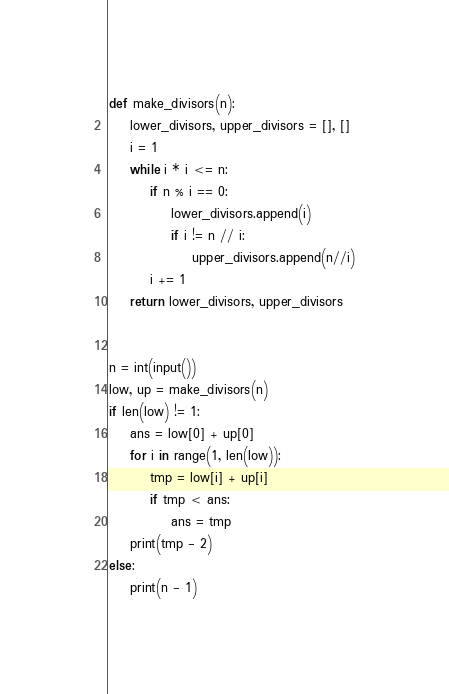<code> <loc_0><loc_0><loc_500><loc_500><_Python_>def make_divisors(n):
    lower_divisors, upper_divisors = [], []
    i = 1
    while i * i <= n:
        if n % i == 0:
            lower_divisors.append(i)
            if i != n // i:
                upper_divisors.append(n//i)
        i += 1
    return lower_divisors, upper_divisors


n = int(input())
low, up = make_divisors(n)
if len(low) != 1:
    ans = low[0] + up[0]
    for i in range(1, len(low)):
        tmp = low[i] + up[i]
        if tmp < ans:
            ans = tmp
    print(tmp - 2)
else:
    print(n - 1)</code> 